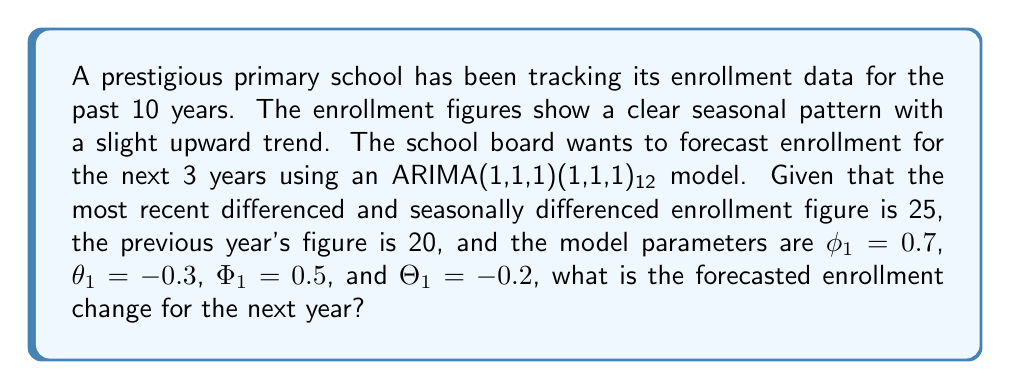Can you answer this question? To solve this problem, we need to use the ARIMA(1,1,1)(1,1,1)₁₂ model equation:

$$(1 - \phi_1B)(1 - \Phi_1B^{12})(1-B)(1-B^{12})y_t = (1 + \theta_1B)(1 + \Theta_1B^{12})\epsilon_t$$

where $B$ is the backshift operator.

Given:
- $\phi_1 = 0.7$ (non-seasonal AR parameter)
- $\theta_1 = -0.3$ (non-seasonal MA parameter)
- $\Phi_1 = 0.5$ (seasonal AR parameter)
- $\Theta_1 = -0.2$ (seasonal MA parameter)
- Most recent differenced and seasonally differenced enrollment: 25
- Previous year's figure: 20

Steps:
1) For a one-step-ahead forecast, we set all future error terms to zero.

2) Expand the equation:

   $y_t - y_{t-1} - y_{t-12} + y_{t-13} - 0.7(y_{t-1} - y_{t-2} - y_{t-13} + y_{t-14}) - 0.5(y_{t-12} - y_{t-13} - y_{t-24} + y_{t-25}) + 0.35(y_{t-13} - y_{t-14} - y_{t-25} + y_{t-26}) = \epsilon_t + 0.3\epsilon_{t-1} + 0.2\epsilon_{t-12} - 0.06\epsilon_{t-13}$

3) For the forecast, we only need the most recent terms:

   $y_t - y_{t-1} - y_{t-12} + y_{t-13} - 0.7(y_{t-1} - y_{t-2} - y_{t-13} + y_{t-14}) = 0$

4) Substitute the known values:

   $y_t - 25 - 20 + (25 + 20) - 0.7(25 - 20) = 0$

5) Solve for $y_t$:

   $y_t = 25 + 20 - 45 + 0.7(5) = 3.5$

The forecasted enrollment change for the next year is 3.5.
Answer: 3.5 